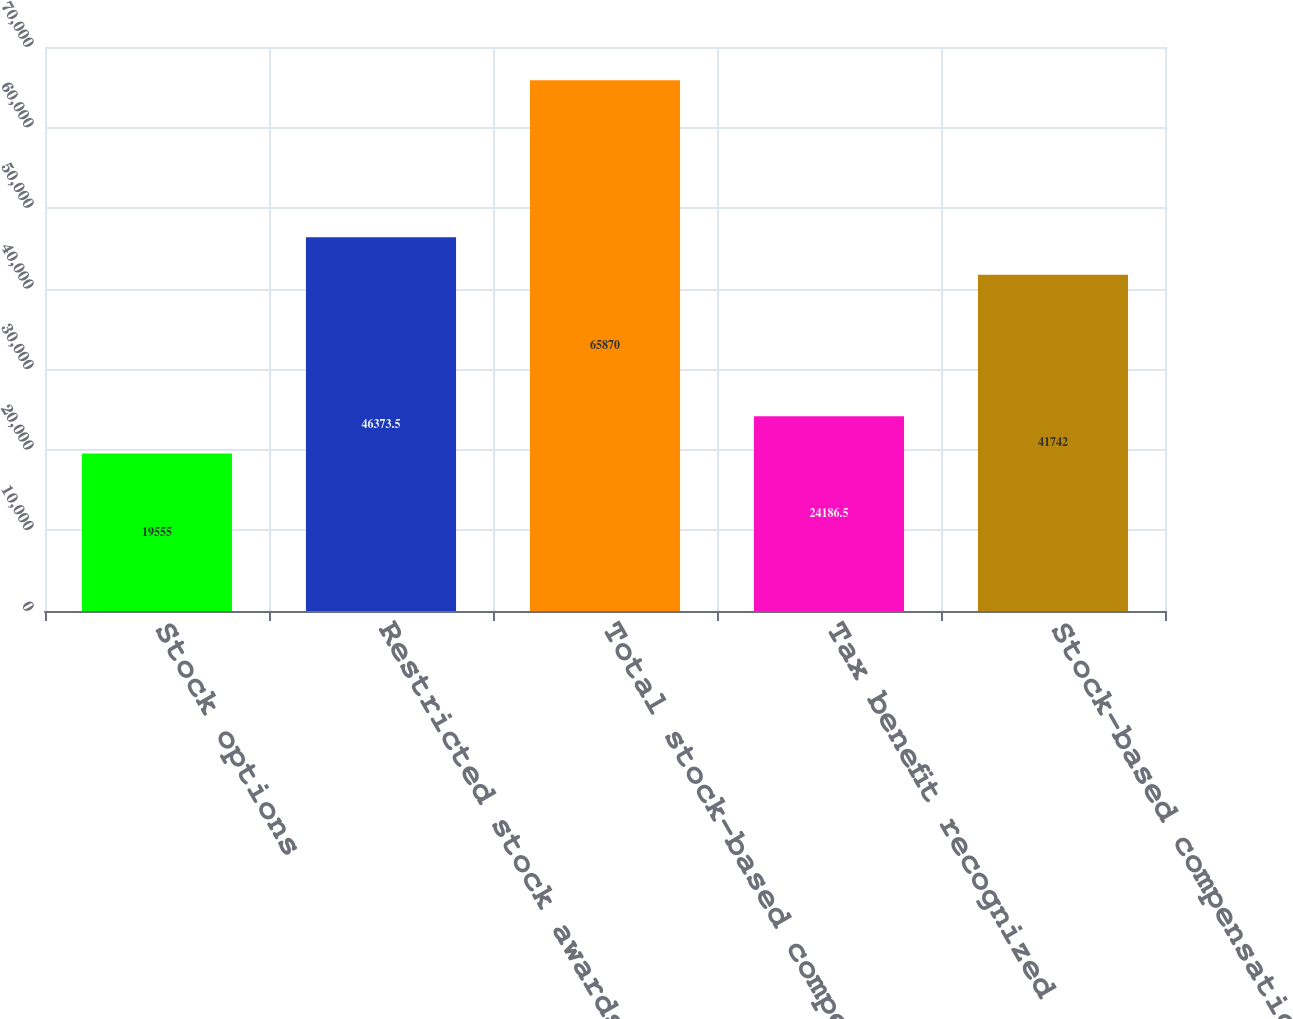Convert chart to OTSL. <chart><loc_0><loc_0><loc_500><loc_500><bar_chart><fcel>Stock options<fcel>Restricted stock awards<fcel>Total stock-based compensation<fcel>Tax benefit recognized<fcel>Stock-based compensation<nl><fcel>19555<fcel>46373.5<fcel>65870<fcel>24186.5<fcel>41742<nl></chart> 